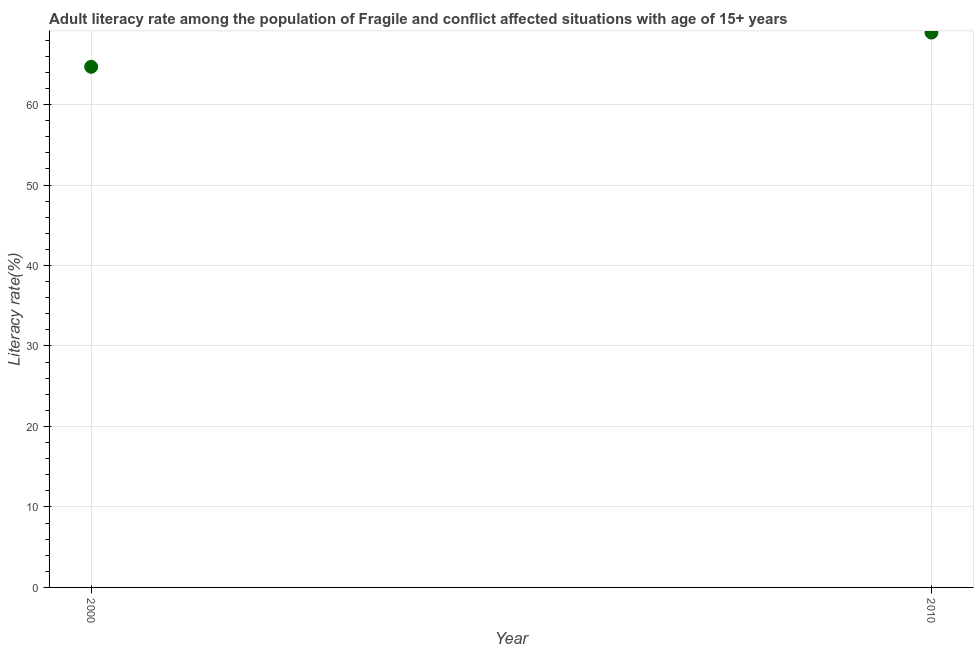What is the adult literacy rate in 2010?
Your answer should be compact. 68.95. Across all years, what is the maximum adult literacy rate?
Offer a terse response. 68.95. Across all years, what is the minimum adult literacy rate?
Offer a very short reply. 64.69. What is the sum of the adult literacy rate?
Your answer should be very brief. 133.63. What is the difference between the adult literacy rate in 2000 and 2010?
Ensure brevity in your answer.  -4.26. What is the average adult literacy rate per year?
Ensure brevity in your answer.  66.82. What is the median adult literacy rate?
Provide a succinct answer. 66.82. In how many years, is the adult literacy rate greater than 52 %?
Your answer should be very brief. 2. Do a majority of the years between 2000 and 2010 (inclusive) have adult literacy rate greater than 12 %?
Offer a terse response. Yes. What is the ratio of the adult literacy rate in 2000 to that in 2010?
Give a very brief answer. 0.94. Is the adult literacy rate in 2000 less than that in 2010?
Provide a succinct answer. Yes. In how many years, is the adult literacy rate greater than the average adult literacy rate taken over all years?
Your response must be concise. 1. Does the adult literacy rate monotonically increase over the years?
Keep it short and to the point. Yes. How many years are there in the graph?
Offer a terse response. 2. What is the difference between two consecutive major ticks on the Y-axis?
Give a very brief answer. 10. Does the graph contain grids?
Make the answer very short. Yes. What is the title of the graph?
Offer a very short reply. Adult literacy rate among the population of Fragile and conflict affected situations with age of 15+ years. What is the label or title of the X-axis?
Offer a terse response. Year. What is the label or title of the Y-axis?
Your answer should be compact. Literacy rate(%). What is the Literacy rate(%) in 2000?
Your answer should be very brief. 64.69. What is the Literacy rate(%) in 2010?
Give a very brief answer. 68.95. What is the difference between the Literacy rate(%) in 2000 and 2010?
Your answer should be very brief. -4.26. What is the ratio of the Literacy rate(%) in 2000 to that in 2010?
Ensure brevity in your answer.  0.94. 